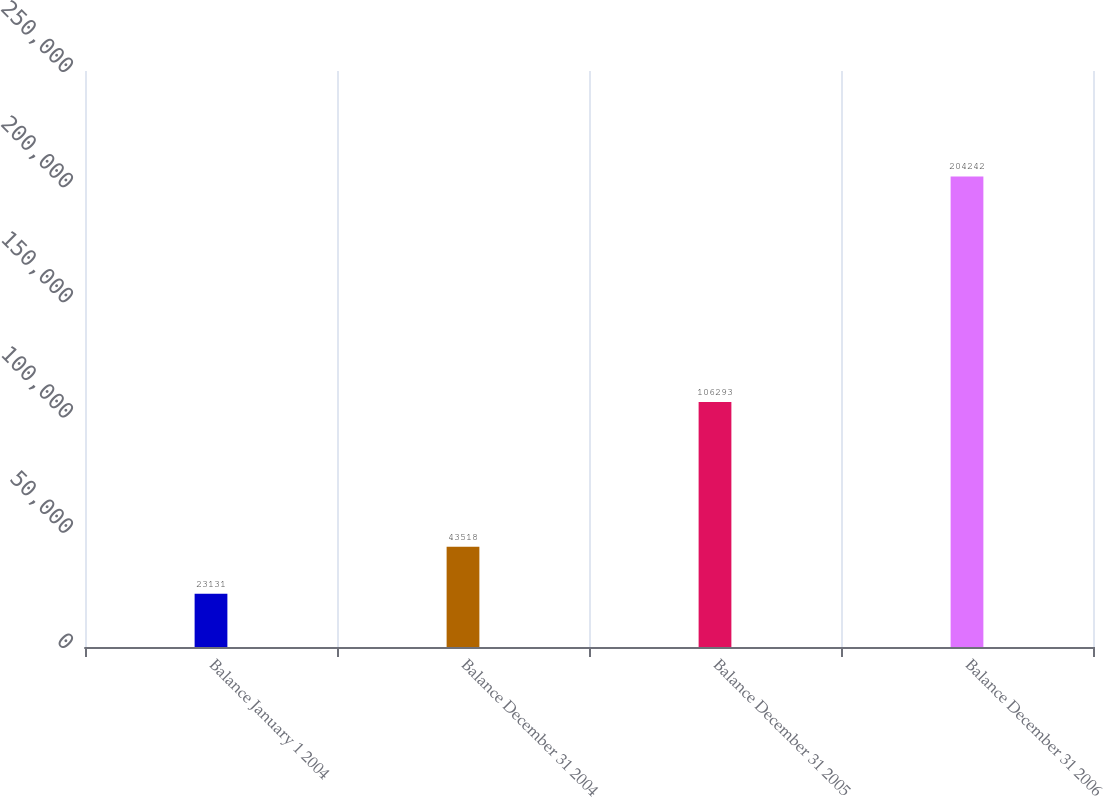Convert chart to OTSL. <chart><loc_0><loc_0><loc_500><loc_500><bar_chart><fcel>Balance January 1 2004<fcel>Balance December 31 2004<fcel>Balance December 31 2005<fcel>Balance December 31 2006<nl><fcel>23131<fcel>43518<fcel>106293<fcel>204242<nl></chart> 